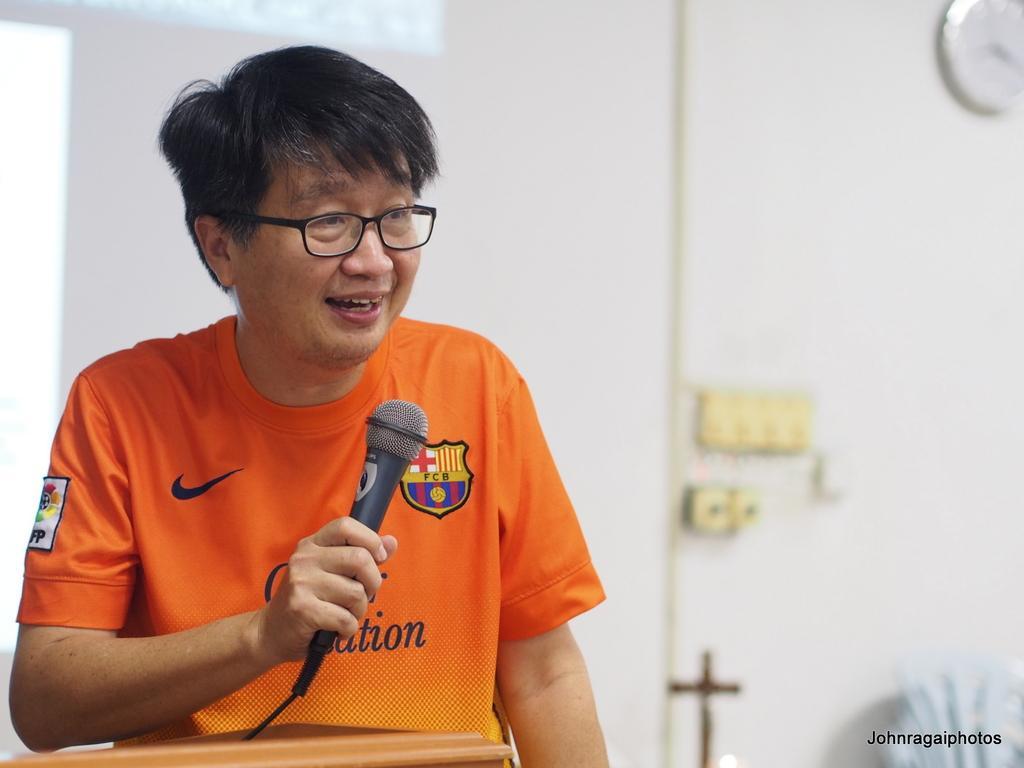How would you summarize this image in a sentence or two? Here we can see a man holding a mike in his hand and in front of him there is an object. In the background we can see a clock and some other objects on the wall and on the right at the bottom we can see a chair and on the left we can see a truncated glass. 